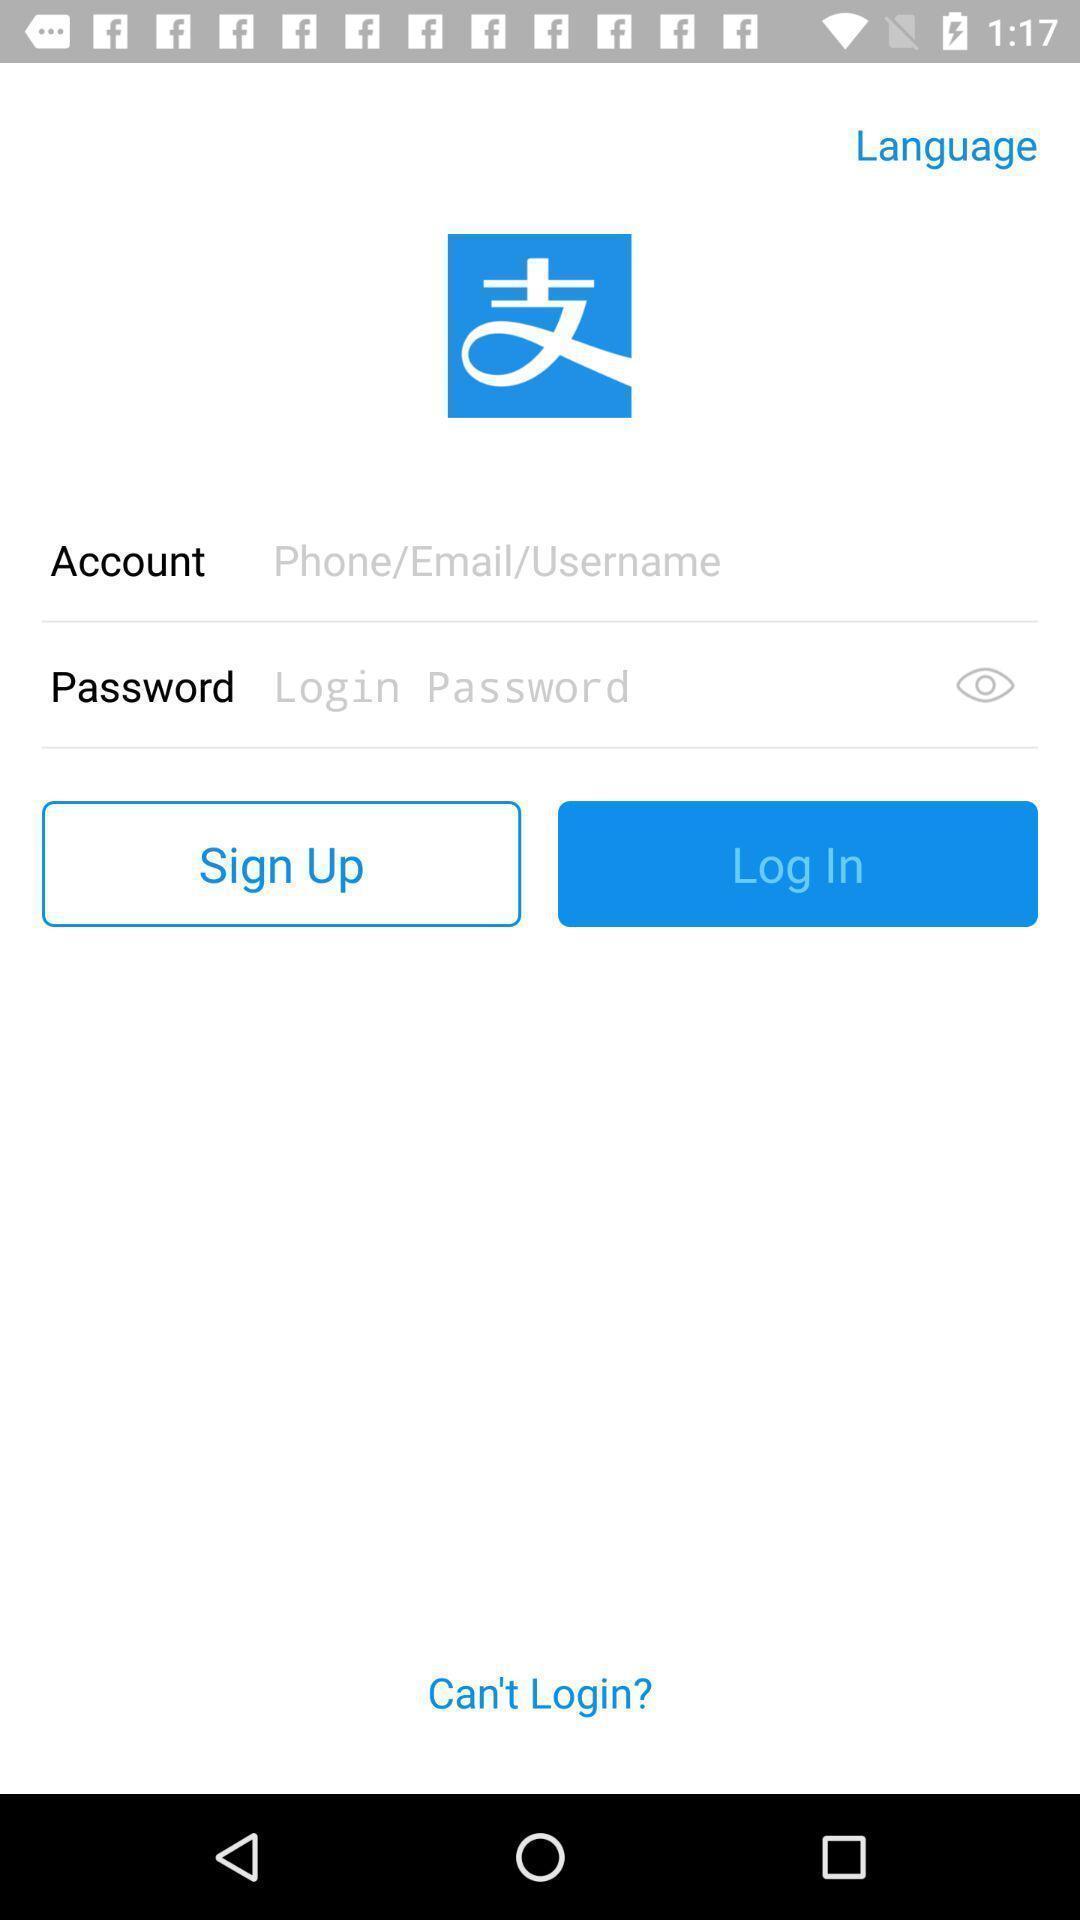What details can you identify in this image? Welcome page displaying to enter details. 